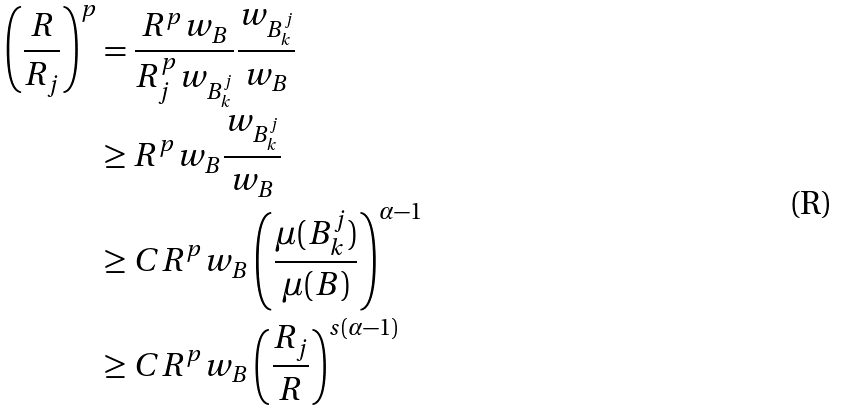<formula> <loc_0><loc_0><loc_500><loc_500>\left ( \frac { R } { R _ { j } } \right ) ^ { p } & = \frac { R ^ { p } w _ { B } } { R _ { j } ^ { p } w _ { B _ { k } ^ { j } } } \frac { w _ { B _ { k } ^ { j } } } { w _ { B } } \\ & \geq R ^ { p } w _ { B } \frac { w _ { B _ { k } ^ { j } } } { w _ { B } } \\ & \geq C R ^ { p } w _ { B } \left ( \frac { \mu ( B _ { k } ^ { j } ) } { \mu ( B ) } \right ) ^ { \alpha - 1 } \\ & \geq C R ^ { p } w _ { B } \left ( \frac { R _ { j } } { R } \right ) ^ { s ( \alpha - 1 ) }</formula> 